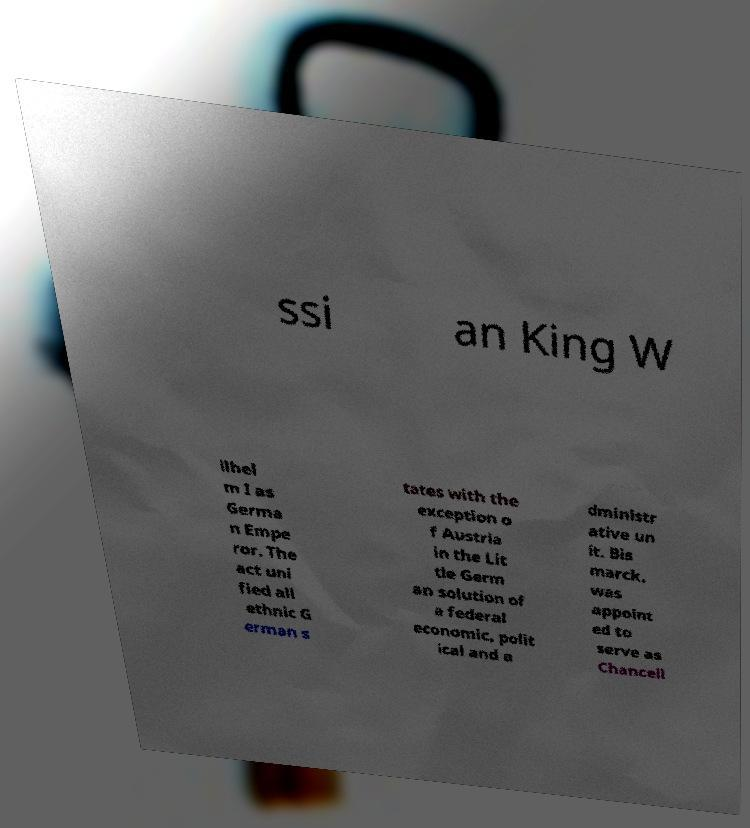Please identify and transcribe the text found in this image. ssi an King W ilhel m I as Germa n Empe ror. The act uni fied all ethnic G erman s tates with the exception o f Austria in the Lit tle Germ an solution of a federal economic, polit ical and a dministr ative un it. Bis marck, was appoint ed to serve as Chancell 